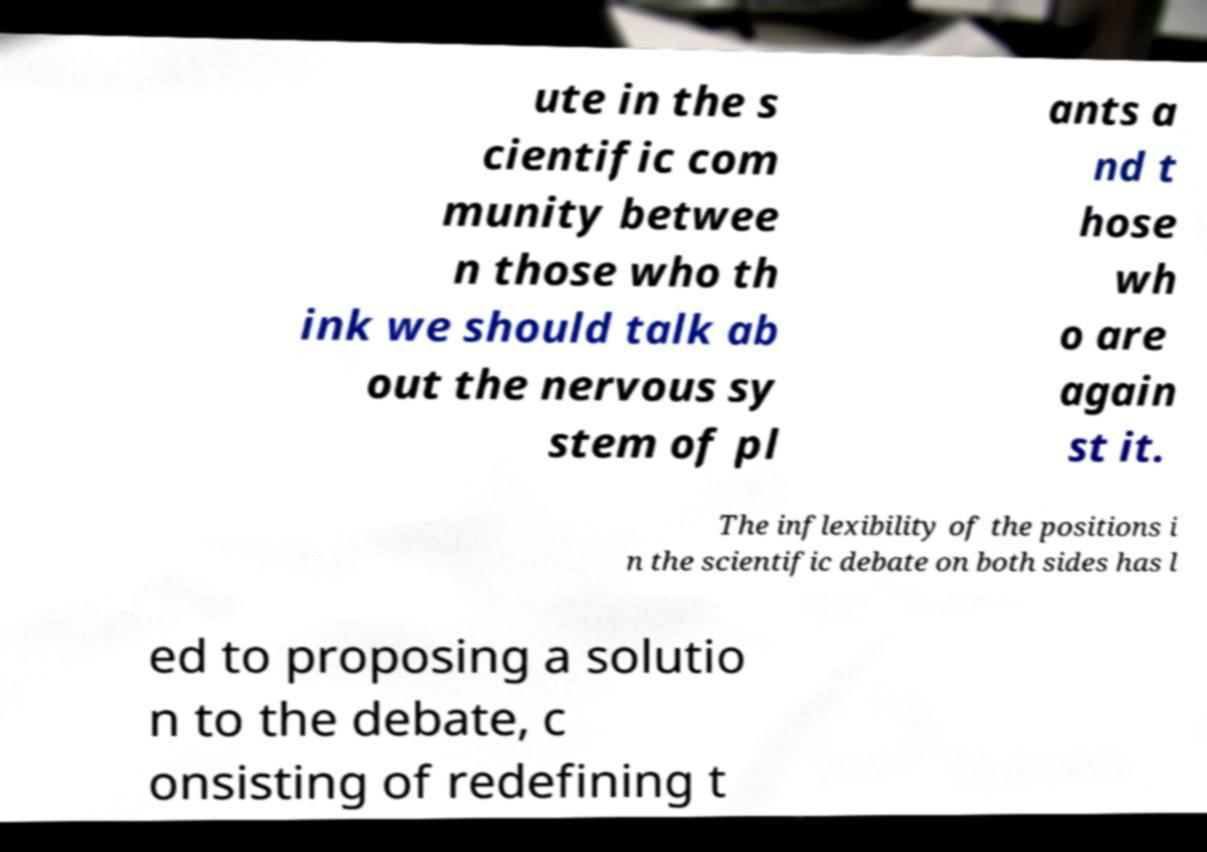For documentation purposes, I need the text within this image transcribed. Could you provide that? ute in the s cientific com munity betwee n those who th ink we should talk ab out the nervous sy stem of pl ants a nd t hose wh o are again st it. The inflexibility of the positions i n the scientific debate on both sides has l ed to proposing a solutio n to the debate, c onsisting of redefining t 